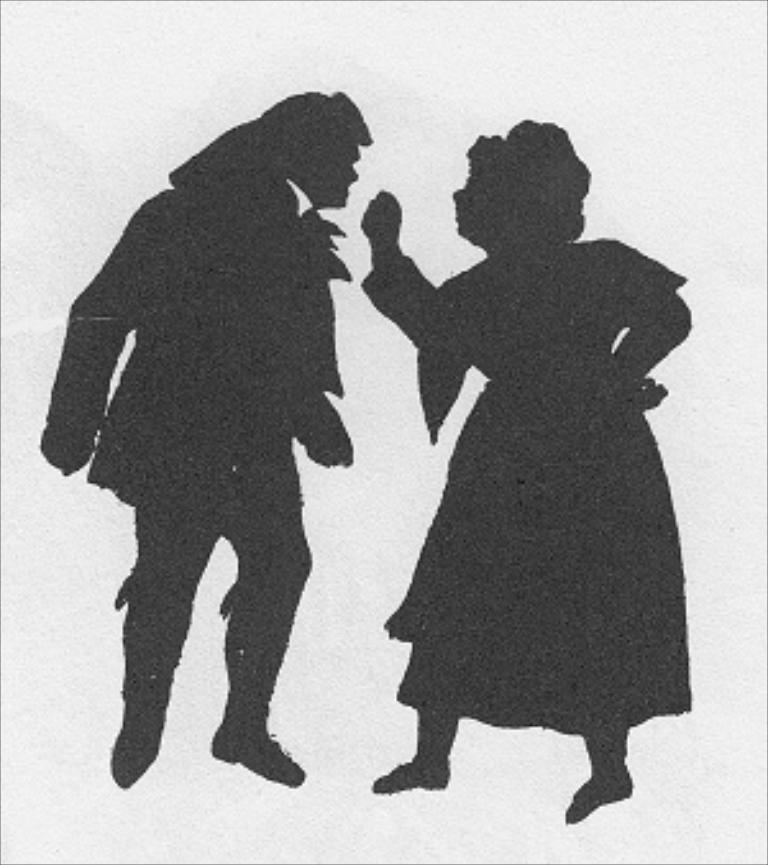Can you describe this image briefly? There is a black color picture of a man and a woman. In the background it is blurred. 